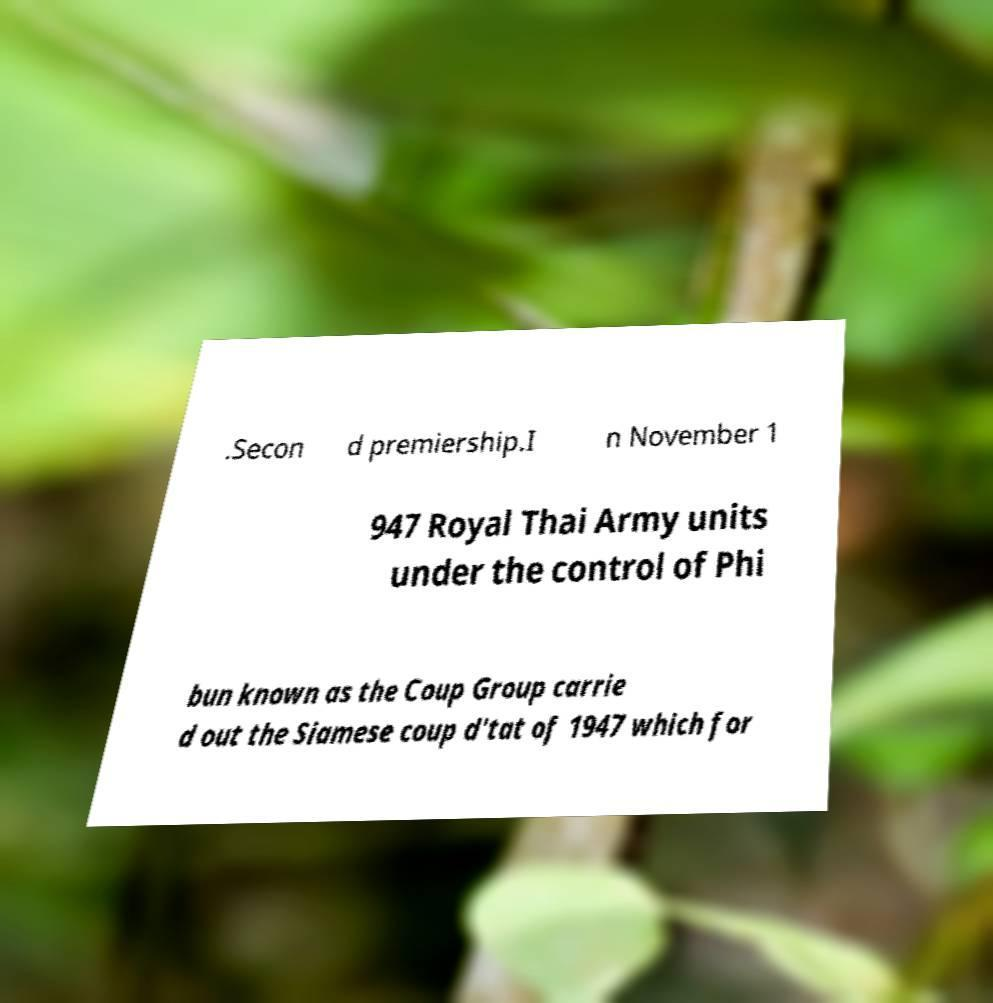What messages or text are displayed in this image? I need them in a readable, typed format. .Secon d premiership.I n November 1 947 Royal Thai Army units under the control of Phi bun known as the Coup Group carrie d out the Siamese coup d'tat of 1947 which for 